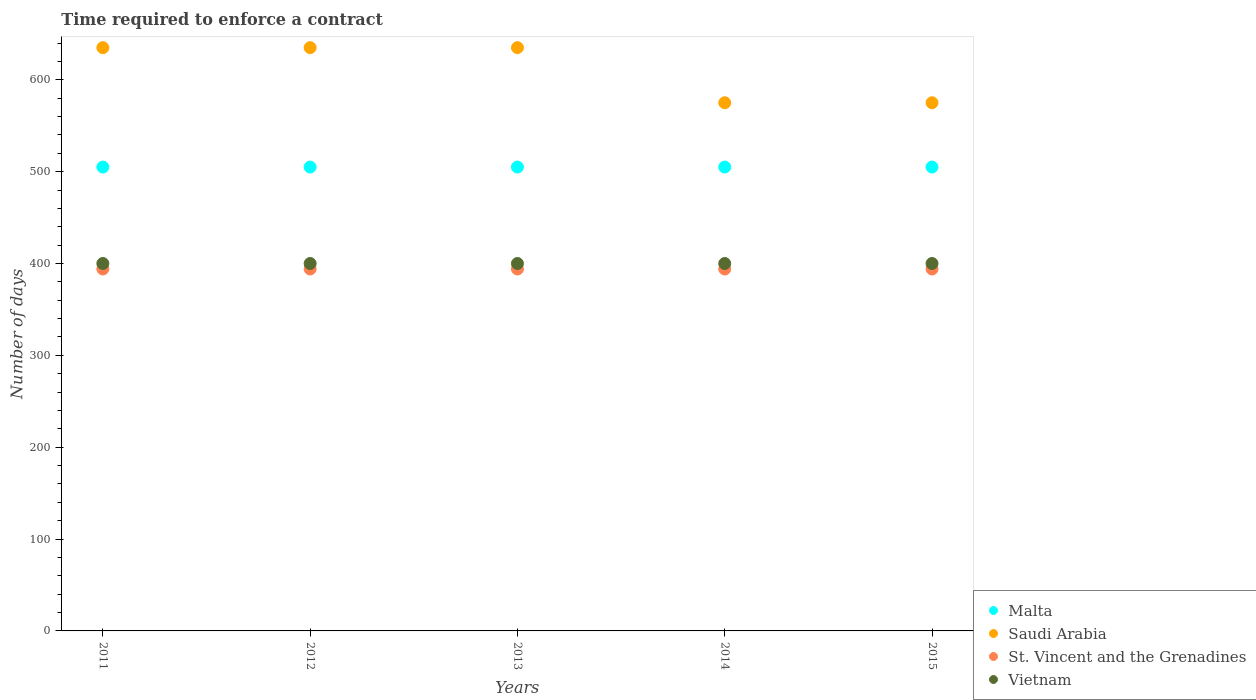What is the number of days required to enforce a contract in Saudi Arabia in 2013?
Your answer should be very brief. 635. Across all years, what is the maximum number of days required to enforce a contract in St. Vincent and the Grenadines?
Your answer should be very brief. 394. Across all years, what is the minimum number of days required to enforce a contract in Vietnam?
Your answer should be very brief. 400. What is the total number of days required to enforce a contract in Malta in the graph?
Your answer should be compact. 2525. What is the difference between the number of days required to enforce a contract in Malta in 2011 and the number of days required to enforce a contract in Saudi Arabia in 2012?
Your answer should be very brief. -130. What is the average number of days required to enforce a contract in Saudi Arabia per year?
Your answer should be compact. 611. In the year 2011, what is the difference between the number of days required to enforce a contract in Malta and number of days required to enforce a contract in St. Vincent and the Grenadines?
Your answer should be compact. 111. In how many years, is the number of days required to enforce a contract in Saudi Arabia greater than 180 days?
Offer a very short reply. 5. Is the sum of the number of days required to enforce a contract in St. Vincent and the Grenadines in 2011 and 2015 greater than the maximum number of days required to enforce a contract in Saudi Arabia across all years?
Provide a succinct answer. Yes. Does the number of days required to enforce a contract in Vietnam monotonically increase over the years?
Your answer should be compact. No. Is the number of days required to enforce a contract in St. Vincent and the Grenadines strictly less than the number of days required to enforce a contract in Malta over the years?
Offer a terse response. Yes. Are the values on the major ticks of Y-axis written in scientific E-notation?
Your answer should be compact. No. Does the graph contain any zero values?
Provide a succinct answer. No. Where does the legend appear in the graph?
Ensure brevity in your answer.  Bottom right. How are the legend labels stacked?
Your answer should be compact. Vertical. What is the title of the graph?
Keep it short and to the point. Time required to enforce a contract. What is the label or title of the X-axis?
Make the answer very short. Years. What is the label or title of the Y-axis?
Your answer should be compact. Number of days. What is the Number of days of Malta in 2011?
Keep it short and to the point. 505. What is the Number of days in Saudi Arabia in 2011?
Provide a short and direct response. 635. What is the Number of days in St. Vincent and the Grenadines in 2011?
Ensure brevity in your answer.  394. What is the Number of days in Malta in 2012?
Your answer should be very brief. 505. What is the Number of days in Saudi Arabia in 2012?
Your response must be concise. 635. What is the Number of days of St. Vincent and the Grenadines in 2012?
Your answer should be compact. 394. What is the Number of days of Vietnam in 2012?
Ensure brevity in your answer.  400. What is the Number of days in Malta in 2013?
Make the answer very short. 505. What is the Number of days of Saudi Arabia in 2013?
Your response must be concise. 635. What is the Number of days of St. Vincent and the Grenadines in 2013?
Your response must be concise. 394. What is the Number of days of Vietnam in 2013?
Your response must be concise. 400. What is the Number of days in Malta in 2014?
Offer a terse response. 505. What is the Number of days in Saudi Arabia in 2014?
Give a very brief answer. 575. What is the Number of days of St. Vincent and the Grenadines in 2014?
Keep it short and to the point. 394. What is the Number of days of Vietnam in 2014?
Provide a succinct answer. 400. What is the Number of days of Malta in 2015?
Keep it short and to the point. 505. What is the Number of days in Saudi Arabia in 2015?
Ensure brevity in your answer.  575. What is the Number of days in St. Vincent and the Grenadines in 2015?
Offer a very short reply. 394. What is the Number of days of Vietnam in 2015?
Offer a very short reply. 400. Across all years, what is the maximum Number of days in Malta?
Your answer should be compact. 505. Across all years, what is the maximum Number of days in Saudi Arabia?
Your response must be concise. 635. Across all years, what is the maximum Number of days of St. Vincent and the Grenadines?
Your answer should be very brief. 394. Across all years, what is the minimum Number of days in Malta?
Keep it short and to the point. 505. Across all years, what is the minimum Number of days of Saudi Arabia?
Make the answer very short. 575. Across all years, what is the minimum Number of days of St. Vincent and the Grenadines?
Your answer should be very brief. 394. Across all years, what is the minimum Number of days in Vietnam?
Ensure brevity in your answer.  400. What is the total Number of days in Malta in the graph?
Your answer should be very brief. 2525. What is the total Number of days in Saudi Arabia in the graph?
Provide a succinct answer. 3055. What is the total Number of days in St. Vincent and the Grenadines in the graph?
Ensure brevity in your answer.  1970. What is the difference between the Number of days in St. Vincent and the Grenadines in 2011 and that in 2012?
Ensure brevity in your answer.  0. What is the difference between the Number of days in Vietnam in 2011 and that in 2012?
Offer a very short reply. 0. What is the difference between the Number of days in Saudi Arabia in 2011 and that in 2014?
Your answer should be compact. 60. What is the difference between the Number of days in St. Vincent and the Grenadines in 2011 and that in 2014?
Offer a very short reply. 0. What is the difference between the Number of days of Vietnam in 2011 and that in 2014?
Your response must be concise. 0. What is the difference between the Number of days of Malta in 2011 and that in 2015?
Your response must be concise. 0. What is the difference between the Number of days in Saudi Arabia in 2011 and that in 2015?
Your answer should be very brief. 60. What is the difference between the Number of days in St. Vincent and the Grenadines in 2011 and that in 2015?
Your response must be concise. 0. What is the difference between the Number of days in Malta in 2012 and that in 2013?
Give a very brief answer. 0. What is the difference between the Number of days in St. Vincent and the Grenadines in 2012 and that in 2013?
Provide a succinct answer. 0. What is the difference between the Number of days in St. Vincent and the Grenadines in 2012 and that in 2014?
Offer a terse response. 0. What is the difference between the Number of days in Vietnam in 2012 and that in 2014?
Give a very brief answer. 0. What is the difference between the Number of days in Malta in 2012 and that in 2015?
Give a very brief answer. 0. What is the difference between the Number of days in St. Vincent and the Grenadines in 2012 and that in 2015?
Your response must be concise. 0. What is the difference between the Number of days in Malta in 2013 and that in 2014?
Offer a very short reply. 0. What is the difference between the Number of days in Saudi Arabia in 2013 and that in 2014?
Your response must be concise. 60. What is the difference between the Number of days in St. Vincent and the Grenadines in 2013 and that in 2014?
Provide a succinct answer. 0. What is the difference between the Number of days in Malta in 2013 and that in 2015?
Provide a succinct answer. 0. What is the difference between the Number of days of St. Vincent and the Grenadines in 2013 and that in 2015?
Your response must be concise. 0. What is the difference between the Number of days of Saudi Arabia in 2014 and that in 2015?
Your response must be concise. 0. What is the difference between the Number of days of Malta in 2011 and the Number of days of Saudi Arabia in 2012?
Provide a succinct answer. -130. What is the difference between the Number of days in Malta in 2011 and the Number of days in St. Vincent and the Grenadines in 2012?
Give a very brief answer. 111. What is the difference between the Number of days of Malta in 2011 and the Number of days of Vietnam in 2012?
Your answer should be very brief. 105. What is the difference between the Number of days of Saudi Arabia in 2011 and the Number of days of St. Vincent and the Grenadines in 2012?
Your answer should be compact. 241. What is the difference between the Number of days of Saudi Arabia in 2011 and the Number of days of Vietnam in 2012?
Give a very brief answer. 235. What is the difference between the Number of days of St. Vincent and the Grenadines in 2011 and the Number of days of Vietnam in 2012?
Your answer should be very brief. -6. What is the difference between the Number of days of Malta in 2011 and the Number of days of Saudi Arabia in 2013?
Ensure brevity in your answer.  -130. What is the difference between the Number of days in Malta in 2011 and the Number of days in St. Vincent and the Grenadines in 2013?
Your answer should be very brief. 111. What is the difference between the Number of days of Malta in 2011 and the Number of days of Vietnam in 2013?
Provide a succinct answer. 105. What is the difference between the Number of days of Saudi Arabia in 2011 and the Number of days of St. Vincent and the Grenadines in 2013?
Give a very brief answer. 241. What is the difference between the Number of days of Saudi Arabia in 2011 and the Number of days of Vietnam in 2013?
Keep it short and to the point. 235. What is the difference between the Number of days in Malta in 2011 and the Number of days in Saudi Arabia in 2014?
Your answer should be compact. -70. What is the difference between the Number of days of Malta in 2011 and the Number of days of St. Vincent and the Grenadines in 2014?
Give a very brief answer. 111. What is the difference between the Number of days in Malta in 2011 and the Number of days in Vietnam in 2014?
Provide a succinct answer. 105. What is the difference between the Number of days in Saudi Arabia in 2011 and the Number of days in St. Vincent and the Grenadines in 2014?
Your answer should be very brief. 241. What is the difference between the Number of days of Saudi Arabia in 2011 and the Number of days of Vietnam in 2014?
Offer a very short reply. 235. What is the difference between the Number of days in St. Vincent and the Grenadines in 2011 and the Number of days in Vietnam in 2014?
Ensure brevity in your answer.  -6. What is the difference between the Number of days in Malta in 2011 and the Number of days in Saudi Arabia in 2015?
Provide a succinct answer. -70. What is the difference between the Number of days of Malta in 2011 and the Number of days of St. Vincent and the Grenadines in 2015?
Offer a terse response. 111. What is the difference between the Number of days of Malta in 2011 and the Number of days of Vietnam in 2015?
Your response must be concise. 105. What is the difference between the Number of days of Saudi Arabia in 2011 and the Number of days of St. Vincent and the Grenadines in 2015?
Provide a short and direct response. 241. What is the difference between the Number of days in Saudi Arabia in 2011 and the Number of days in Vietnam in 2015?
Make the answer very short. 235. What is the difference between the Number of days of St. Vincent and the Grenadines in 2011 and the Number of days of Vietnam in 2015?
Offer a very short reply. -6. What is the difference between the Number of days of Malta in 2012 and the Number of days of Saudi Arabia in 2013?
Your answer should be very brief. -130. What is the difference between the Number of days of Malta in 2012 and the Number of days of St. Vincent and the Grenadines in 2013?
Offer a very short reply. 111. What is the difference between the Number of days of Malta in 2012 and the Number of days of Vietnam in 2013?
Your response must be concise. 105. What is the difference between the Number of days in Saudi Arabia in 2012 and the Number of days in St. Vincent and the Grenadines in 2013?
Make the answer very short. 241. What is the difference between the Number of days of Saudi Arabia in 2012 and the Number of days of Vietnam in 2013?
Give a very brief answer. 235. What is the difference between the Number of days in Malta in 2012 and the Number of days in Saudi Arabia in 2014?
Make the answer very short. -70. What is the difference between the Number of days in Malta in 2012 and the Number of days in St. Vincent and the Grenadines in 2014?
Provide a short and direct response. 111. What is the difference between the Number of days in Malta in 2012 and the Number of days in Vietnam in 2014?
Keep it short and to the point. 105. What is the difference between the Number of days of Saudi Arabia in 2012 and the Number of days of St. Vincent and the Grenadines in 2014?
Provide a succinct answer. 241. What is the difference between the Number of days of Saudi Arabia in 2012 and the Number of days of Vietnam in 2014?
Provide a short and direct response. 235. What is the difference between the Number of days of St. Vincent and the Grenadines in 2012 and the Number of days of Vietnam in 2014?
Make the answer very short. -6. What is the difference between the Number of days of Malta in 2012 and the Number of days of Saudi Arabia in 2015?
Make the answer very short. -70. What is the difference between the Number of days in Malta in 2012 and the Number of days in St. Vincent and the Grenadines in 2015?
Offer a terse response. 111. What is the difference between the Number of days in Malta in 2012 and the Number of days in Vietnam in 2015?
Offer a very short reply. 105. What is the difference between the Number of days in Saudi Arabia in 2012 and the Number of days in St. Vincent and the Grenadines in 2015?
Give a very brief answer. 241. What is the difference between the Number of days of Saudi Arabia in 2012 and the Number of days of Vietnam in 2015?
Keep it short and to the point. 235. What is the difference between the Number of days of Malta in 2013 and the Number of days of Saudi Arabia in 2014?
Offer a terse response. -70. What is the difference between the Number of days of Malta in 2013 and the Number of days of St. Vincent and the Grenadines in 2014?
Offer a terse response. 111. What is the difference between the Number of days in Malta in 2013 and the Number of days in Vietnam in 2014?
Your answer should be very brief. 105. What is the difference between the Number of days of Saudi Arabia in 2013 and the Number of days of St. Vincent and the Grenadines in 2014?
Keep it short and to the point. 241. What is the difference between the Number of days in Saudi Arabia in 2013 and the Number of days in Vietnam in 2014?
Your response must be concise. 235. What is the difference between the Number of days in Malta in 2013 and the Number of days in Saudi Arabia in 2015?
Offer a very short reply. -70. What is the difference between the Number of days of Malta in 2013 and the Number of days of St. Vincent and the Grenadines in 2015?
Keep it short and to the point. 111. What is the difference between the Number of days in Malta in 2013 and the Number of days in Vietnam in 2015?
Give a very brief answer. 105. What is the difference between the Number of days of Saudi Arabia in 2013 and the Number of days of St. Vincent and the Grenadines in 2015?
Provide a succinct answer. 241. What is the difference between the Number of days of Saudi Arabia in 2013 and the Number of days of Vietnam in 2015?
Make the answer very short. 235. What is the difference between the Number of days in Malta in 2014 and the Number of days in Saudi Arabia in 2015?
Give a very brief answer. -70. What is the difference between the Number of days in Malta in 2014 and the Number of days in St. Vincent and the Grenadines in 2015?
Give a very brief answer. 111. What is the difference between the Number of days of Malta in 2014 and the Number of days of Vietnam in 2015?
Make the answer very short. 105. What is the difference between the Number of days of Saudi Arabia in 2014 and the Number of days of St. Vincent and the Grenadines in 2015?
Offer a very short reply. 181. What is the difference between the Number of days of Saudi Arabia in 2014 and the Number of days of Vietnam in 2015?
Your response must be concise. 175. What is the difference between the Number of days in St. Vincent and the Grenadines in 2014 and the Number of days in Vietnam in 2015?
Provide a succinct answer. -6. What is the average Number of days of Malta per year?
Offer a very short reply. 505. What is the average Number of days in Saudi Arabia per year?
Ensure brevity in your answer.  611. What is the average Number of days of St. Vincent and the Grenadines per year?
Ensure brevity in your answer.  394. In the year 2011, what is the difference between the Number of days in Malta and Number of days in Saudi Arabia?
Provide a succinct answer. -130. In the year 2011, what is the difference between the Number of days of Malta and Number of days of St. Vincent and the Grenadines?
Offer a terse response. 111. In the year 2011, what is the difference between the Number of days in Malta and Number of days in Vietnam?
Make the answer very short. 105. In the year 2011, what is the difference between the Number of days of Saudi Arabia and Number of days of St. Vincent and the Grenadines?
Your response must be concise. 241. In the year 2011, what is the difference between the Number of days of Saudi Arabia and Number of days of Vietnam?
Your answer should be very brief. 235. In the year 2012, what is the difference between the Number of days in Malta and Number of days in Saudi Arabia?
Give a very brief answer. -130. In the year 2012, what is the difference between the Number of days in Malta and Number of days in St. Vincent and the Grenadines?
Offer a very short reply. 111. In the year 2012, what is the difference between the Number of days of Malta and Number of days of Vietnam?
Your answer should be compact. 105. In the year 2012, what is the difference between the Number of days of Saudi Arabia and Number of days of St. Vincent and the Grenadines?
Your answer should be compact. 241. In the year 2012, what is the difference between the Number of days of Saudi Arabia and Number of days of Vietnam?
Offer a very short reply. 235. In the year 2013, what is the difference between the Number of days in Malta and Number of days in Saudi Arabia?
Give a very brief answer. -130. In the year 2013, what is the difference between the Number of days of Malta and Number of days of St. Vincent and the Grenadines?
Your answer should be compact. 111. In the year 2013, what is the difference between the Number of days in Malta and Number of days in Vietnam?
Your answer should be compact. 105. In the year 2013, what is the difference between the Number of days of Saudi Arabia and Number of days of St. Vincent and the Grenadines?
Provide a short and direct response. 241. In the year 2013, what is the difference between the Number of days in Saudi Arabia and Number of days in Vietnam?
Provide a short and direct response. 235. In the year 2013, what is the difference between the Number of days in St. Vincent and the Grenadines and Number of days in Vietnam?
Make the answer very short. -6. In the year 2014, what is the difference between the Number of days in Malta and Number of days in Saudi Arabia?
Ensure brevity in your answer.  -70. In the year 2014, what is the difference between the Number of days of Malta and Number of days of St. Vincent and the Grenadines?
Your answer should be compact. 111. In the year 2014, what is the difference between the Number of days of Malta and Number of days of Vietnam?
Offer a very short reply. 105. In the year 2014, what is the difference between the Number of days in Saudi Arabia and Number of days in St. Vincent and the Grenadines?
Your answer should be compact. 181. In the year 2014, what is the difference between the Number of days of Saudi Arabia and Number of days of Vietnam?
Your response must be concise. 175. In the year 2015, what is the difference between the Number of days in Malta and Number of days in Saudi Arabia?
Offer a terse response. -70. In the year 2015, what is the difference between the Number of days of Malta and Number of days of St. Vincent and the Grenadines?
Ensure brevity in your answer.  111. In the year 2015, what is the difference between the Number of days in Malta and Number of days in Vietnam?
Your answer should be very brief. 105. In the year 2015, what is the difference between the Number of days in Saudi Arabia and Number of days in St. Vincent and the Grenadines?
Your response must be concise. 181. In the year 2015, what is the difference between the Number of days of Saudi Arabia and Number of days of Vietnam?
Your answer should be very brief. 175. What is the ratio of the Number of days of Malta in 2011 to that in 2012?
Your answer should be compact. 1. What is the ratio of the Number of days in Vietnam in 2011 to that in 2012?
Provide a short and direct response. 1. What is the ratio of the Number of days in Malta in 2011 to that in 2013?
Make the answer very short. 1. What is the ratio of the Number of days of Saudi Arabia in 2011 to that in 2013?
Provide a succinct answer. 1. What is the ratio of the Number of days in Vietnam in 2011 to that in 2013?
Offer a terse response. 1. What is the ratio of the Number of days of Malta in 2011 to that in 2014?
Ensure brevity in your answer.  1. What is the ratio of the Number of days of Saudi Arabia in 2011 to that in 2014?
Provide a short and direct response. 1.1. What is the ratio of the Number of days of Malta in 2011 to that in 2015?
Offer a terse response. 1. What is the ratio of the Number of days in Saudi Arabia in 2011 to that in 2015?
Your response must be concise. 1.1. What is the ratio of the Number of days in St. Vincent and the Grenadines in 2011 to that in 2015?
Keep it short and to the point. 1. What is the ratio of the Number of days of Vietnam in 2011 to that in 2015?
Offer a terse response. 1. What is the ratio of the Number of days of Malta in 2012 to that in 2013?
Make the answer very short. 1. What is the ratio of the Number of days of St. Vincent and the Grenadines in 2012 to that in 2013?
Offer a terse response. 1. What is the ratio of the Number of days of Vietnam in 2012 to that in 2013?
Your answer should be very brief. 1. What is the ratio of the Number of days of Malta in 2012 to that in 2014?
Provide a succinct answer. 1. What is the ratio of the Number of days of Saudi Arabia in 2012 to that in 2014?
Your answer should be very brief. 1.1. What is the ratio of the Number of days of Vietnam in 2012 to that in 2014?
Make the answer very short. 1. What is the ratio of the Number of days in Malta in 2012 to that in 2015?
Ensure brevity in your answer.  1. What is the ratio of the Number of days in Saudi Arabia in 2012 to that in 2015?
Ensure brevity in your answer.  1.1. What is the ratio of the Number of days in Malta in 2013 to that in 2014?
Your answer should be compact. 1. What is the ratio of the Number of days in Saudi Arabia in 2013 to that in 2014?
Offer a very short reply. 1.1. What is the ratio of the Number of days in Saudi Arabia in 2013 to that in 2015?
Provide a succinct answer. 1.1. What is the ratio of the Number of days in St. Vincent and the Grenadines in 2013 to that in 2015?
Provide a short and direct response. 1. What is the ratio of the Number of days of Vietnam in 2013 to that in 2015?
Offer a very short reply. 1. What is the ratio of the Number of days in St. Vincent and the Grenadines in 2014 to that in 2015?
Give a very brief answer. 1. What is the difference between the highest and the second highest Number of days of Malta?
Offer a terse response. 0. What is the difference between the highest and the second highest Number of days in Saudi Arabia?
Ensure brevity in your answer.  0. What is the difference between the highest and the second highest Number of days of Vietnam?
Ensure brevity in your answer.  0. What is the difference between the highest and the lowest Number of days in Malta?
Your answer should be compact. 0. 